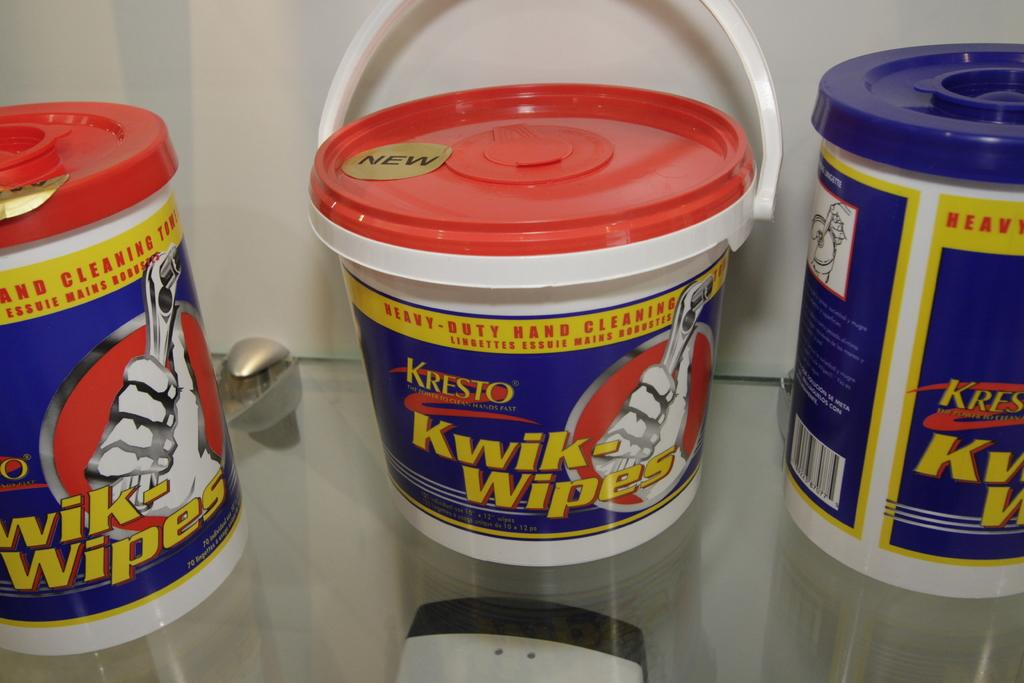Provide a one-sentence caption for the provided image. Three red and blue containers of Kresto Kwik-Wipes are on the shelf. 